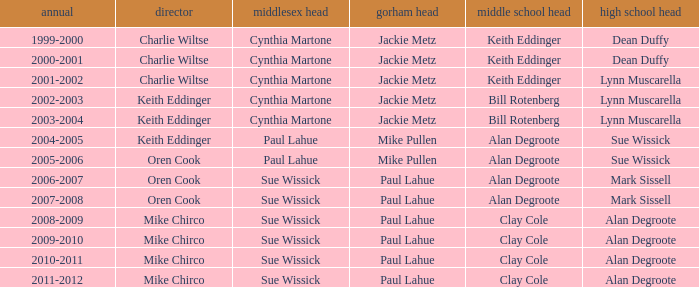Who were the superintendent(s) when the middle school principal was alan degroote, the gorham principal was paul lahue, and the year was 2006-2007? Oren Cook. 